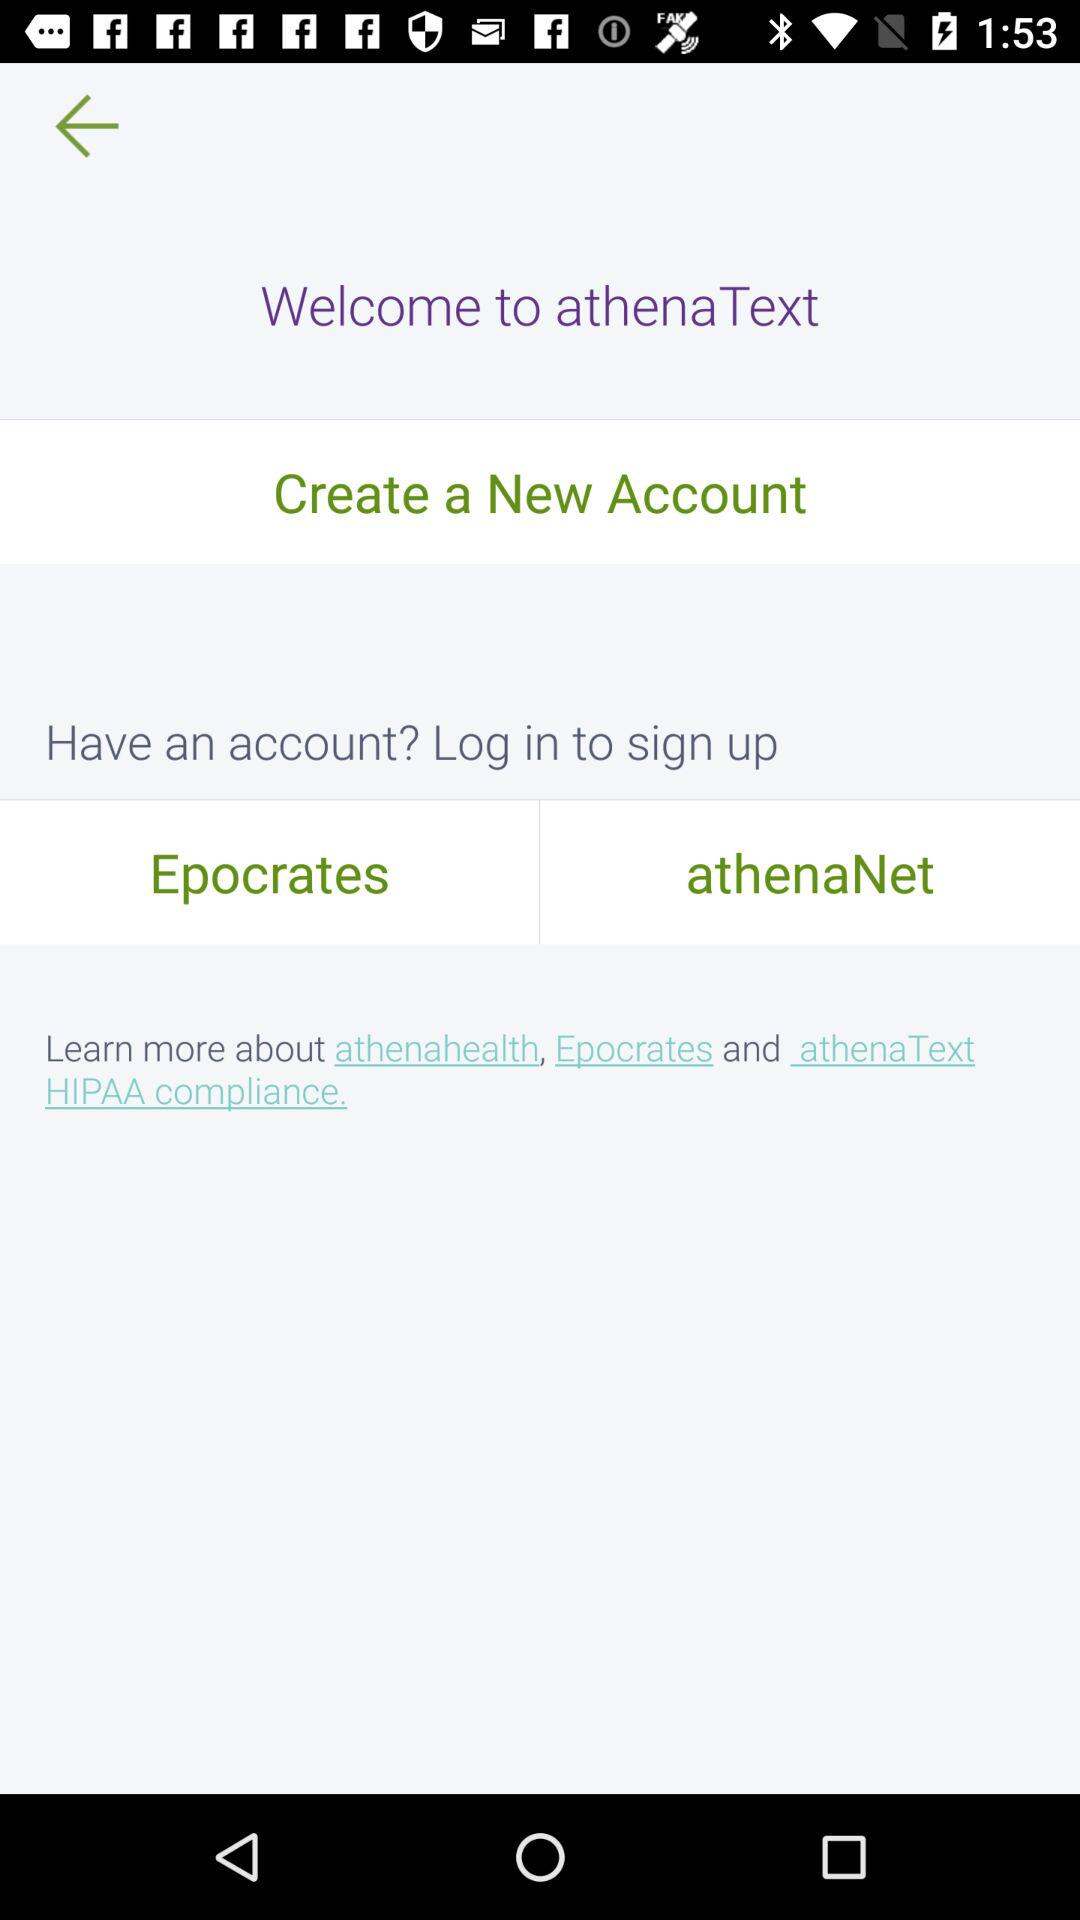What options are given to login? The given options are: "Epocrates" and "athenaNet". 